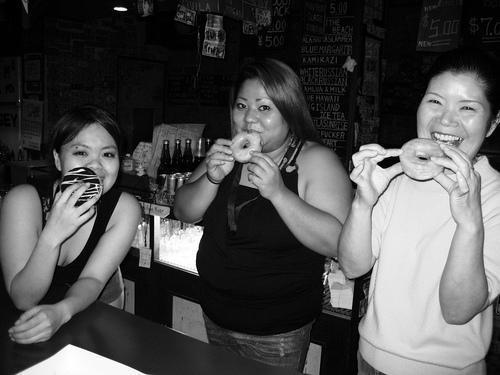How many people are in the picture?
Give a very brief answer. 3. How many bottles are the picture?
Give a very brief answer. 4. How many glazed donuts are in the picture?
Give a very brief answer. 2. How many people are wearing black shirts?
Give a very brief answer. 2. How many woman are holding a donut with one hand?
Give a very brief answer. 1. 